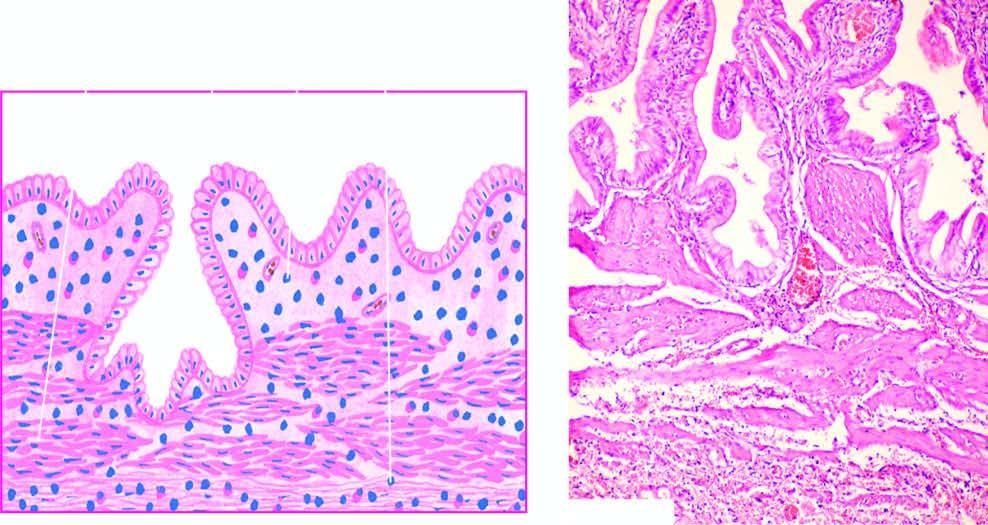s there penetration of epithelium-lined spaces into the gallbladder wall in an area?
Answer the question using a single word or phrase. Yes 